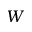Convert formula to latex. <formula><loc_0><loc_0><loc_500><loc_500>W</formula> 